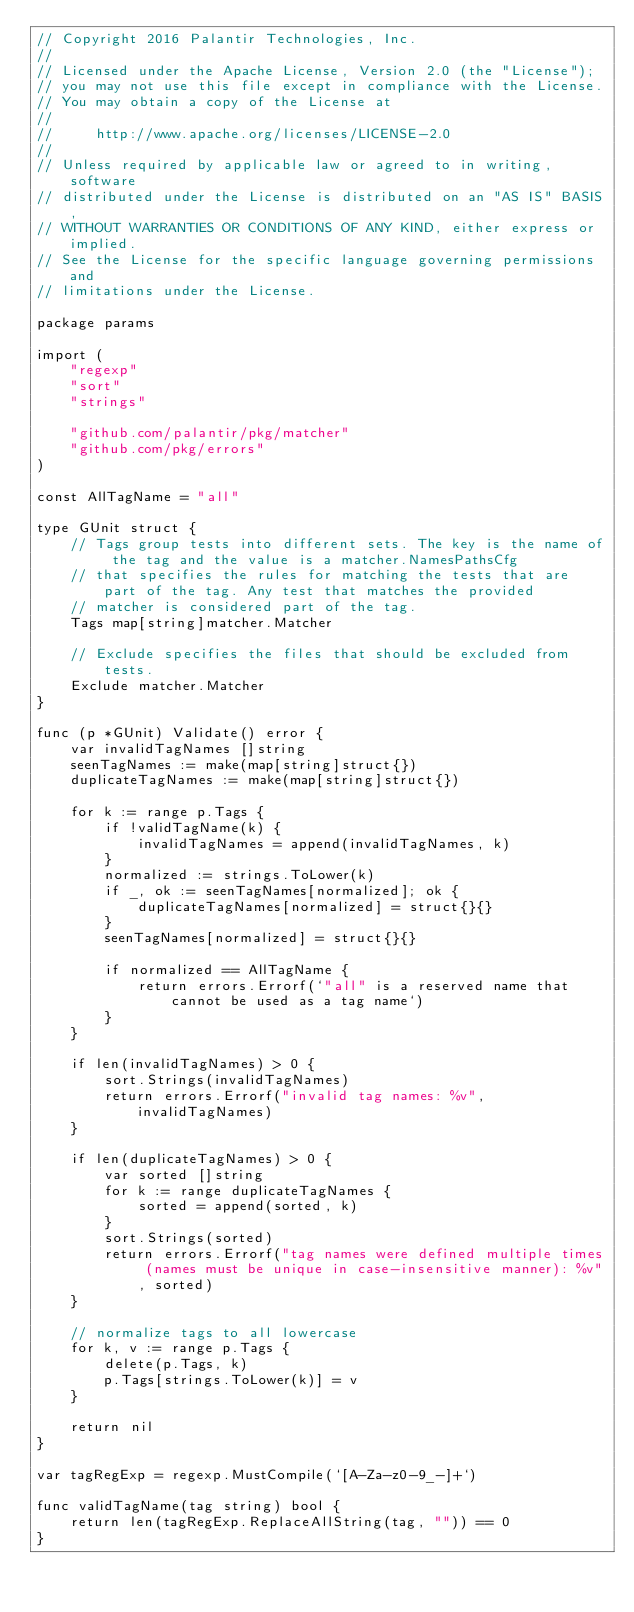<code> <loc_0><loc_0><loc_500><loc_500><_Go_>// Copyright 2016 Palantir Technologies, Inc.
//
// Licensed under the Apache License, Version 2.0 (the "License");
// you may not use this file except in compliance with the License.
// You may obtain a copy of the License at
//
//     http://www.apache.org/licenses/LICENSE-2.0
//
// Unless required by applicable law or agreed to in writing, software
// distributed under the License is distributed on an "AS IS" BASIS,
// WITHOUT WARRANTIES OR CONDITIONS OF ANY KIND, either express or implied.
// See the License for the specific language governing permissions and
// limitations under the License.

package params

import (
	"regexp"
	"sort"
	"strings"

	"github.com/palantir/pkg/matcher"
	"github.com/pkg/errors"
)

const AllTagName = "all"

type GUnit struct {
	// Tags group tests into different sets. The key is the name of the tag and the value is a matcher.NamesPathsCfg
	// that specifies the rules for matching the tests that are part of the tag. Any test that matches the provided
	// matcher is considered part of the tag.
	Tags map[string]matcher.Matcher

	// Exclude specifies the files that should be excluded from tests.
	Exclude matcher.Matcher
}

func (p *GUnit) Validate() error {
	var invalidTagNames []string
	seenTagNames := make(map[string]struct{})
	duplicateTagNames := make(map[string]struct{})

	for k := range p.Tags {
		if !validTagName(k) {
			invalidTagNames = append(invalidTagNames, k)
		}
		normalized := strings.ToLower(k)
		if _, ok := seenTagNames[normalized]; ok {
			duplicateTagNames[normalized] = struct{}{}
		}
		seenTagNames[normalized] = struct{}{}

		if normalized == AllTagName {
			return errors.Errorf(`"all" is a reserved name that cannot be used as a tag name`)
		}
	}

	if len(invalidTagNames) > 0 {
		sort.Strings(invalidTagNames)
		return errors.Errorf("invalid tag names: %v", invalidTagNames)
	}

	if len(duplicateTagNames) > 0 {
		var sorted []string
		for k := range duplicateTagNames {
			sorted = append(sorted, k)
		}
		sort.Strings(sorted)
		return errors.Errorf("tag names were defined multiple times (names must be unique in case-insensitive manner): %v", sorted)
	}

	// normalize tags to all lowercase
	for k, v := range p.Tags {
		delete(p.Tags, k)
		p.Tags[strings.ToLower(k)] = v
	}

	return nil
}

var tagRegExp = regexp.MustCompile(`[A-Za-z0-9_-]+`)

func validTagName(tag string) bool {
	return len(tagRegExp.ReplaceAllString(tag, "")) == 0
}
</code> 